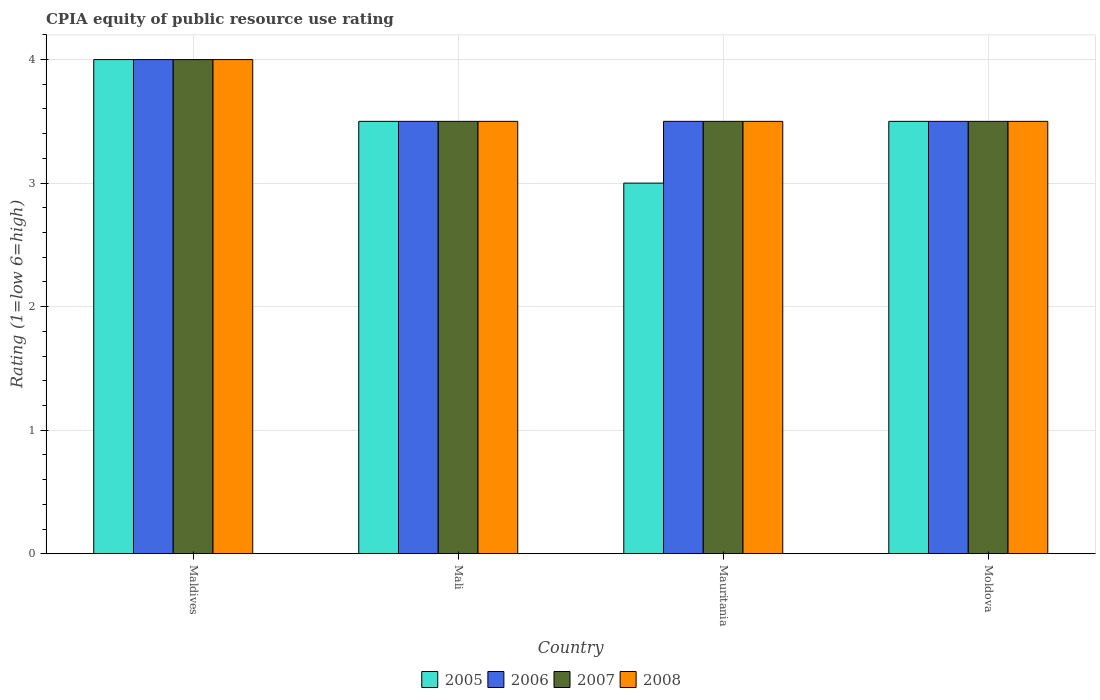How many different coloured bars are there?
Make the answer very short. 4. How many groups of bars are there?
Your answer should be very brief. 4. Are the number of bars on each tick of the X-axis equal?
Provide a succinct answer. Yes. How many bars are there on the 4th tick from the right?
Offer a very short reply. 4. What is the label of the 4th group of bars from the left?
Your answer should be very brief. Moldova. In how many cases, is the number of bars for a given country not equal to the number of legend labels?
Make the answer very short. 0. What is the CPIA rating in 2008 in Moldova?
Provide a succinct answer. 3.5. In which country was the CPIA rating in 2008 maximum?
Give a very brief answer. Maldives. In which country was the CPIA rating in 2005 minimum?
Offer a terse response. Mauritania. What is the total CPIA rating in 2008 in the graph?
Provide a succinct answer. 14.5. What is the average CPIA rating in 2005 per country?
Provide a short and direct response. 3.5. What is the ratio of the CPIA rating in 2005 in Mauritania to that in Moldova?
Your response must be concise. 0.86. Is the CPIA rating in 2007 in Mali less than that in Moldova?
Make the answer very short. No. Is the difference between the CPIA rating in 2007 in Maldives and Moldova greater than the difference between the CPIA rating in 2006 in Maldives and Moldova?
Your answer should be compact. No. Is it the case that in every country, the sum of the CPIA rating in 2006 and CPIA rating in 2007 is greater than the sum of CPIA rating in 2005 and CPIA rating in 2008?
Give a very brief answer. No. Is it the case that in every country, the sum of the CPIA rating in 2008 and CPIA rating in 2007 is greater than the CPIA rating in 2005?
Provide a short and direct response. Yes. How many bars are there?
Offer a terse response. 16. Are all the bars in the graph horizontal?
Provide a short and direct response. No. How many countries are there in the graph?
Offer a very short reply. 4. What is the difference between two consecutive major ticks on the Y-axis?
Offer a very short reply. 1. Does the graph contain grids?
Provide a succinct answer. Yes. How many legend labels are there?
Offer a very short reply. 4. What is the title of the graph?
Keep it short and to the point. CPIA equity of public resource use rating. Does "2012" appear as one of the legend labels in the graph?
Give a very brief answer. No. What is the label or title of the Y-axis?
Provide a succinct answer. Rating (1=low 6=high). What is the Rating (1=low 6=high) of 2005 in Maldives?
Provide a short and direct response. 4. What is the Rating (1=low 6=high) of 2006 in Maldives?
Your response must be concise. 4. What is the Rating (1=low 6=high) of 2007 in Maldives?
Ensure brevity in your answer.  4. What is the Rating (1=low 6=high) in 2008 in Maldives?
Provide a succinct answer. 4. What is the Rating (1=low 6=high) of 2008 in Mali?
Keep it short and to the point. 3.5. What is the Rating (1=low 6=high) in 2005 in Mauritania?
Ensure brevity in your answer.  3. What is the Rating (1=low 6=high) in 2007 in Mauritania?
Make the answer very short. 3.5. What is the Rating (1=low 6=high) of 2008 in Mauritania?
Ensure brevity in your answer.  3.5. What is the Rating (1=low 6=high) in 2007 in Moldova?
Your answer should be compact. 3.5. Across all countries, what is the maximum Rating (1=low 6=high) in 2005?
Offer a terse response. 4. Across all countries, what is the maximum Rating (1=low 6=high) of 2008?
Offer a very short reply. 4. Across all countries, what is the minimum Rating (1=low 6=high) of 2005?
Keep it short and to the point. 3. Across all countries, what is the minimum Rating (1=low 6=high) in 2008?
Your answer should be very brief. 3.5. What is the total Rating (1=low 6=high) of 2007 in the graph?
Make the answer very short. 14.5. What is the total Rating (1=low 6=high) in 2008 in the graph?
Make the answer very short. 14.5. What is the difference between the Rating (1=low 6=high) of 2007 in Maldives and that in Mali?
Provide a succinct answer. 0.5. What is the difference between the Rating (1=low 6=high) in 2008 in Maldives and that in Mali?
Ensure brevity in your answer.  0.5. What is the difference between the Rating (1=low 6=high) in 2005 in Maldives and that in Mauritania?
Provide a short and direct response. 1. What is the difference between the Rating (1=low 6=high) in 2006 in Maldives and that in Mauritania?
Ensure brevity in your answer.  0.5. What is the difference between the Rating (1=low 6=high) in 2008 in Maldives and that in Mauritania?
Keep it short and to the point. 0.5. What is the difference between the Rating (1=low 6=high) in 2005 in Maldives and that in Moldova?
Offer a terse response. 0.5. What is the difference between the Rating (1=low 6=high) of 2008 in Maldives and that in Moldova?
Your answer should be compact. 0.5. What is the difference between the Rating (1=low 6=high) in 2006 in Mali and that in Mauritania?
Provide a short and direct response. 0. What is the difference between the Rating (1=low 6=high) of 2007 in Mali and that in Mauritania?
Keep it short and to the point. 0. What is the difference between the Rating (1=low 6=high) in 2008 in Mali and that in Mauritania?
Make the answer very short. 0. What is the difference between the Rating (1=low 6=high) of 2005 in Mali and that in Moldova?
Give a very brief answer. 0. What is the difference between the Rating (1=low 6=high) in 2005 in Mauritania and that in Moldova?
Offer a terse response. -0.5. What is the difference between the Rating (1=low 6=high) in 2005 in Maldives and the Rating (1=low 6=high) in 2007 in Mali?
Make the answer very short. 0.5. What is the difference between the Rating (1=low 6=high) in 2005 in Maldives and the Rating (1=low 6=high) in 2008 in Mali?
Ensure brevity in your answer.  0.5. What is the difference between the Rating (1=low 6=high) in 2005 in Maldives and the Rating (1=low 6=high) in 2006 in Mauritania?
Ensure brevity in your answer.  0.5. What is the difference between the Rating (1=low 6=high) in 2006 in Maldives and the Rating (1=low 6=high) in 2007 in Mauritania?
Offer a very short reply. 0.5. What is the difference between the Rating (1=low 6=high) of 2006 in Maldives and the Rating (1=low 6=high) of 2008 in Mauritania?
Provide a succinct answer. 0.5. What is the difference between the Rating (1=low 6=high) of 2005 in Maldives and the Rating (1=low 6=high) of 2006 in Moldova?
Make the answer very short. 0.5. What is the difference between the Rating (1=low 6=high) of 2005 in Maldives and the Rating (1=low 6=high) of 2007 in Moldova?
Provide a succinct answer. 0.5. What is the difference between the Rating (1=low 6=high) of 2005 in Mali and the Rating (1=low 6=high) of 2006 in Mauritania?
Your response must be concise. 0. What is the difference between the Rating (1=low 6=high) in 2006 in Mali and the Rating (1=low 6=high) in 2007 in Mauritania?
Give a very brief answer. 0. What is the difference between the Rating (1=low 6=high) of 2005 in Mali and the Rating (1=low 6=high) of 2006 in Moldova?
Your answer should be compact. 0. What is the difference between the Rating (1=low 6=high) in 2005 in Mali and the Rating (1=low 6=high) in 2008 in Moldova?
Your answer should be very brief. 0. What is the difference between the Rating (1=low 6=high) in 2005 in Mauritania and the Rating (1=low 6=high) in 2007 in Moldova?
Your response must be concise. -0.5. What is the average Rating (1=low 6=high) in 2006 per country?
Make the answer very short. 3.62. What is the average Rating (1=low 6=high) in 2007 per country?
Your answer should be compact. 3.62. What is the average Rating (1=low 6=high) of 2008 per country?
Provide a short and direct response. 3.62. What is the difference between the Rating (1=low 6=high) of 2005 and Rating (1=low 6=high) of 2007 in Maldives?
Your answer should be very brief. 0. What is the difference between the Rating (1=low 6=high) of 2005 and Rating (1=low 6=high) of 2008 in Maldives?
Ensure brevity in your answer.  0. What is the difference between the Rating (1=low 6=high) in 2006 and Rating (1=low 6=high) in 2008 in Maldives?
Your answer should be compact. 0. What is the difference between the Rating (1=low 6=high) in 2006 and Rating (1=low 6=high) in 2008 in Mali?
Your answer should be compact. 0. What is the difference between the Rating (1=low 6=high) of 2005 and Rating (1=low 6=high) of 2006 in Mauritania?
Keep it short and to the point. -0.5. What is the difference between the Rating (1=low 6=high) of 2006 and Rating (1=low 6=high) of 2007 in Mauritania?
Provide a short and direct response. 0. What is the difference between the Rating (1=low 6=high) of 2007 and Rating (1=low 6=high) of 2008 in Mauritania?
Keep it short and to the point. 0. What is the difference between the Rating (1=low 6=high) in 2005 and Rating (1=low 6=high) in 2006 in Moldova?
Offer a terse response. 0. What is the difference between the Rating (1=low 6=high) in 2006 and Rating (1=low 6=high) in 2007 in Moldova?
Offer a terse response. 0. What is the difference between the Rating (1=low 6=high) of 2006 and Rating (1=low 6=high) of 2008 in Moldova?
Give a very brief answer. 0. What is the difference between the Rating (1=low 6=high) in 2007 and Rating (1=low 6=high) in 2008 in Moldova?
Keep it short and to the point. 0. What is the ratio of the Rating (1=low 6=high) of 2005 in Maldives to that in Mali?
Offer a very short reply. 1.14. What is the ratio of the Rating (1=low 6=high) in 2006 in Maldives to that in Mali?
Keep it short and to the point. 1.14. What is the ratio of the Rating (1=low 6=high) in 2005 in Maldives to that in Mauritania?
Your response must be concise. 1.33. What is the ratio of the Rating (1=low 6=high) of 2006 in Maldives to that in Mauritania?
Give a very brief answer. 1.14. What is the ratio of the Rating (1=low 6=high) in 2008 in Maldives to that in Mauritania?
Offer a very short reply. 1.14. What is the ratio of the Rating (1=low 6=high) of 2005 in Maldives to that in Moldova?
Give a very brief answer. 1.14. What is the ratio of the Rating (1=low 6=high) in 2007 in Maldives to that in Moldova?
Give a very brief answer. 1.14. What is the ratio of the Rating (1=low 6=high) of 2008 in Maldives to that in Moldova?
Your answer should be very brief. 1.14. What is the ratio of the Rating (1=low 6=high) in 2006 in Mali to that in Mauritania?
Make the answer very short. 1. What is the ratio of the Rating (1=low 6=high) in 2007 in Mali to that in Mauritania?
Give a very brief answer. 1. What is the ratio of the Rating (1=low 6=high) of 2008 in Mali to that in Mauritania?
Provide a short and direct response. 1. What is the ratio of the Rating (1=low 6=high) of 2006 in Mali to that in Moldova?
Your answer should be compact. 1. What is the ratio of the Rating (1=low 6=high) in 2008 in Mali to that in Moldova?
Offer a terse response. 1. What is the ratio of the Rating (1=low 6=high) in 2005 in Mauritania to that in Moldova?
Your response must be concise. 0.86. What is the ratio of the Rating (1=low 6=high) of 2006 in Mauritania to that in Moldova?
Provide a succinct answer. 1. What is the ratio of the Rating (1=low 6=high) in 2007 in Mauritania to that in Moldova?
Provide a succinct answer. 1. What is the ratio of the Rating (1=low 6=high) of 2008 in Mauritania to that in Moldova?
Your response must be concise. 1. What is the difference between the highest and the second highest Rating (1=low 6=high) of 2005?
Offer a terse response. 0.5. What is the difference between the highest and the second highest Rating (1=low 6=high) of 2007?
Provide a succinct answer. 0.5. What is the difference between the highest and the lowest Rating (1=low 6=high) of 2005?
Your answer should be compact. 1. What is the difference between the highest and the lowest Rating (1=low 6=high) of 2006?
Make the answer very short. 0.5. 